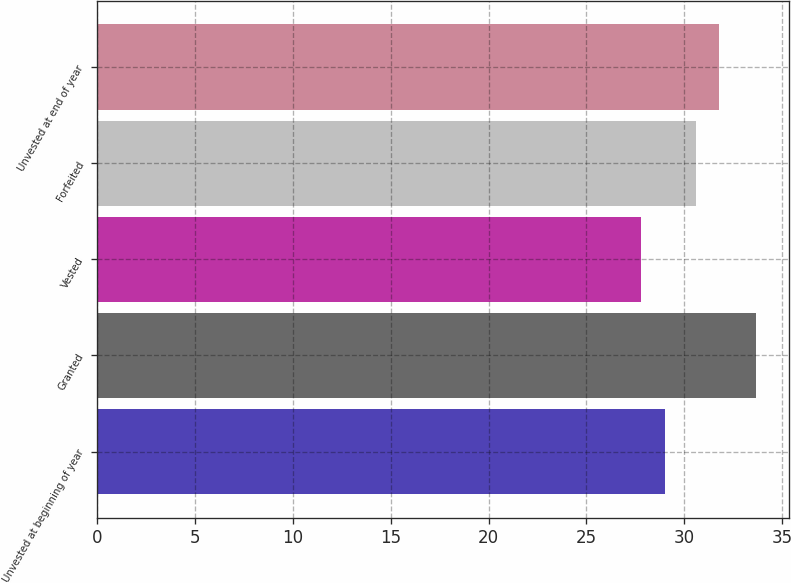Convert chart. <chart><loc_0><loc_0><loc_500><loc_500><bar_chart><fcel>Unvested at beginning of year<fcel>Granted<fcel>Vested<fcel>Forfeited<fcel>Unvested at end of year<nl><fcel>29.02<fcel>33.69<fcel>27.78<fcel>30.58<fcel>31.8<nl></chart> 